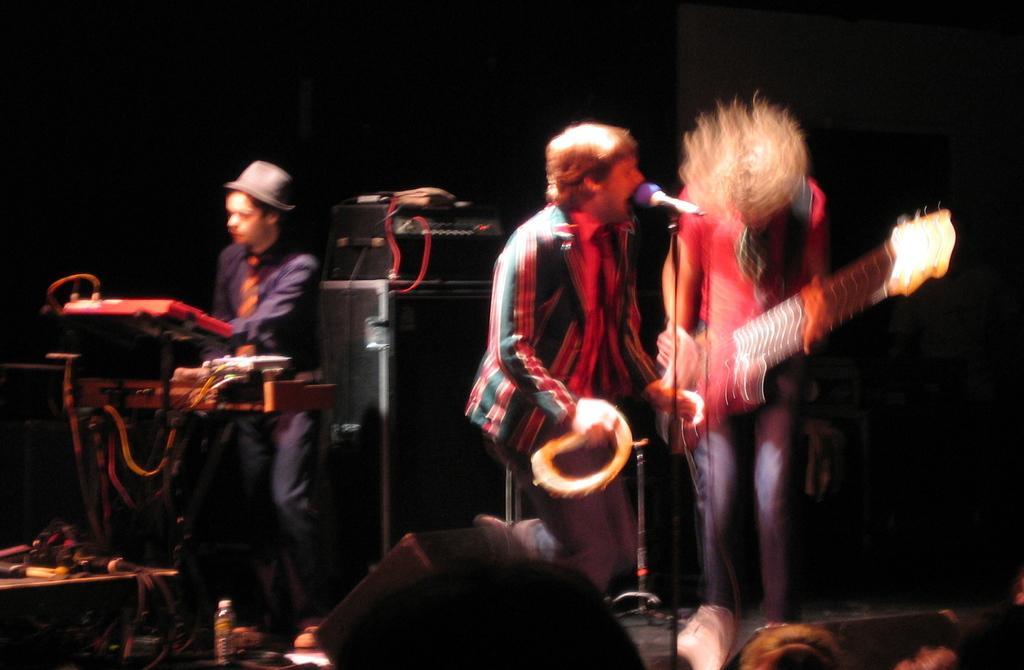Could you give a brief overview of what you see in this image? In this image 2 persons standing and singing a song and playing a guitar , another man standing and playing an instrument and in the back ground we have a speakers , some cables , table and a mike. 